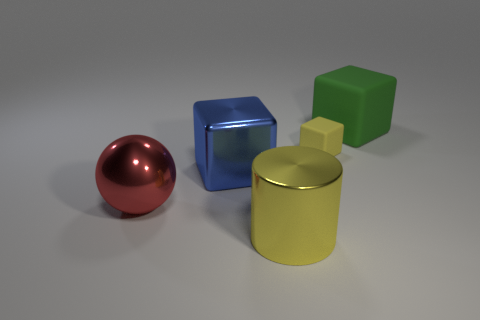The lighting in the scene seems to be coming from a single source. Where is the light originating from based on the shadows? Observing the direction of the shadows cast by each of the objects, we can surmise that the light source is situated off to the right side of the frame, slightly above the horizontal plane of the objects. Shadows extend to the left, which indicates the light is coming from the upper right perspective of the viewer. 